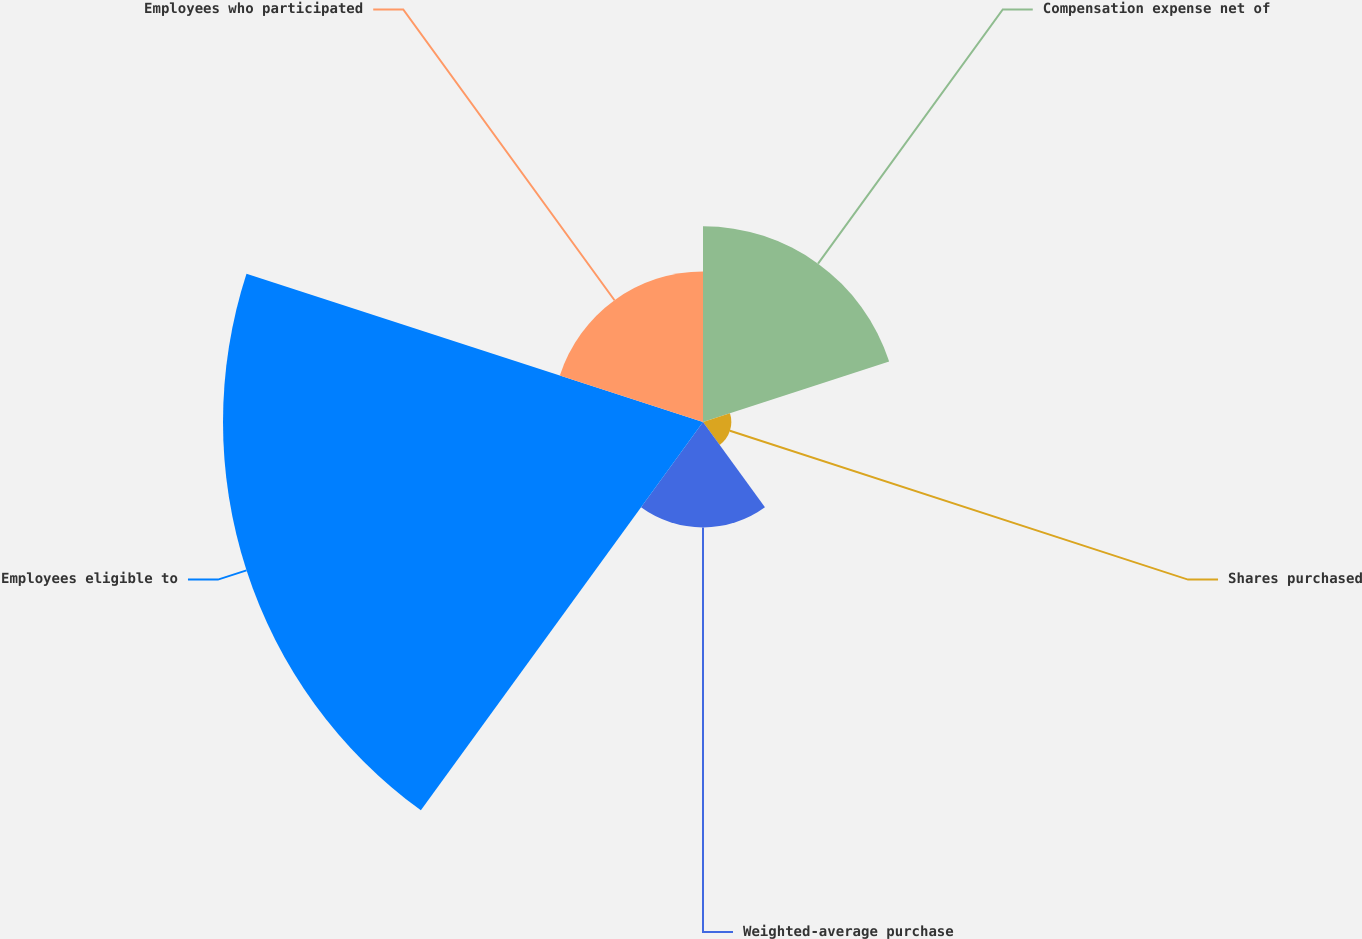Convert chart. <chart><loc_0><loc_0><loc_500><loc_500><pie_chart><fcel>Compensation expense net of<fcel>Shares purchased<fcel>Weighted-average purchase<fcel>Employees eligible to<fcel>Employees who participated<nl><fcel>20.39%<fcel>2.95%<fcel>10.98%<fcel>50.0%<fcel>15.68%<nl></chart> 